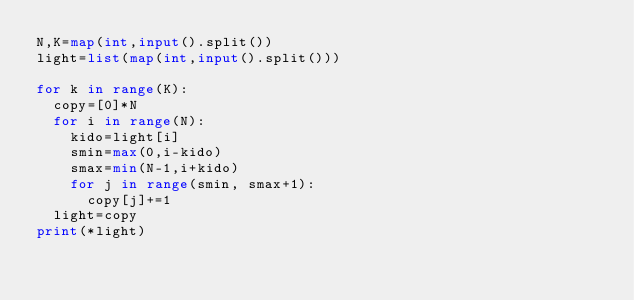Convert code to text. <code><loc_0><loc_0><loc_500><loc_500><_Python_>N,K=map(int,input().split())
light=list(map(int,input().split()))

for k in range(K):
  copy=[0]*N
  for i in range(N):
    kido=light[i]
    smin=max(0,i-kido)
    smax=min(N-1,i+kido)
    for j in range(smin, smax+1):
      copy[j]+=1
  light=copy
print(*light)</code> 